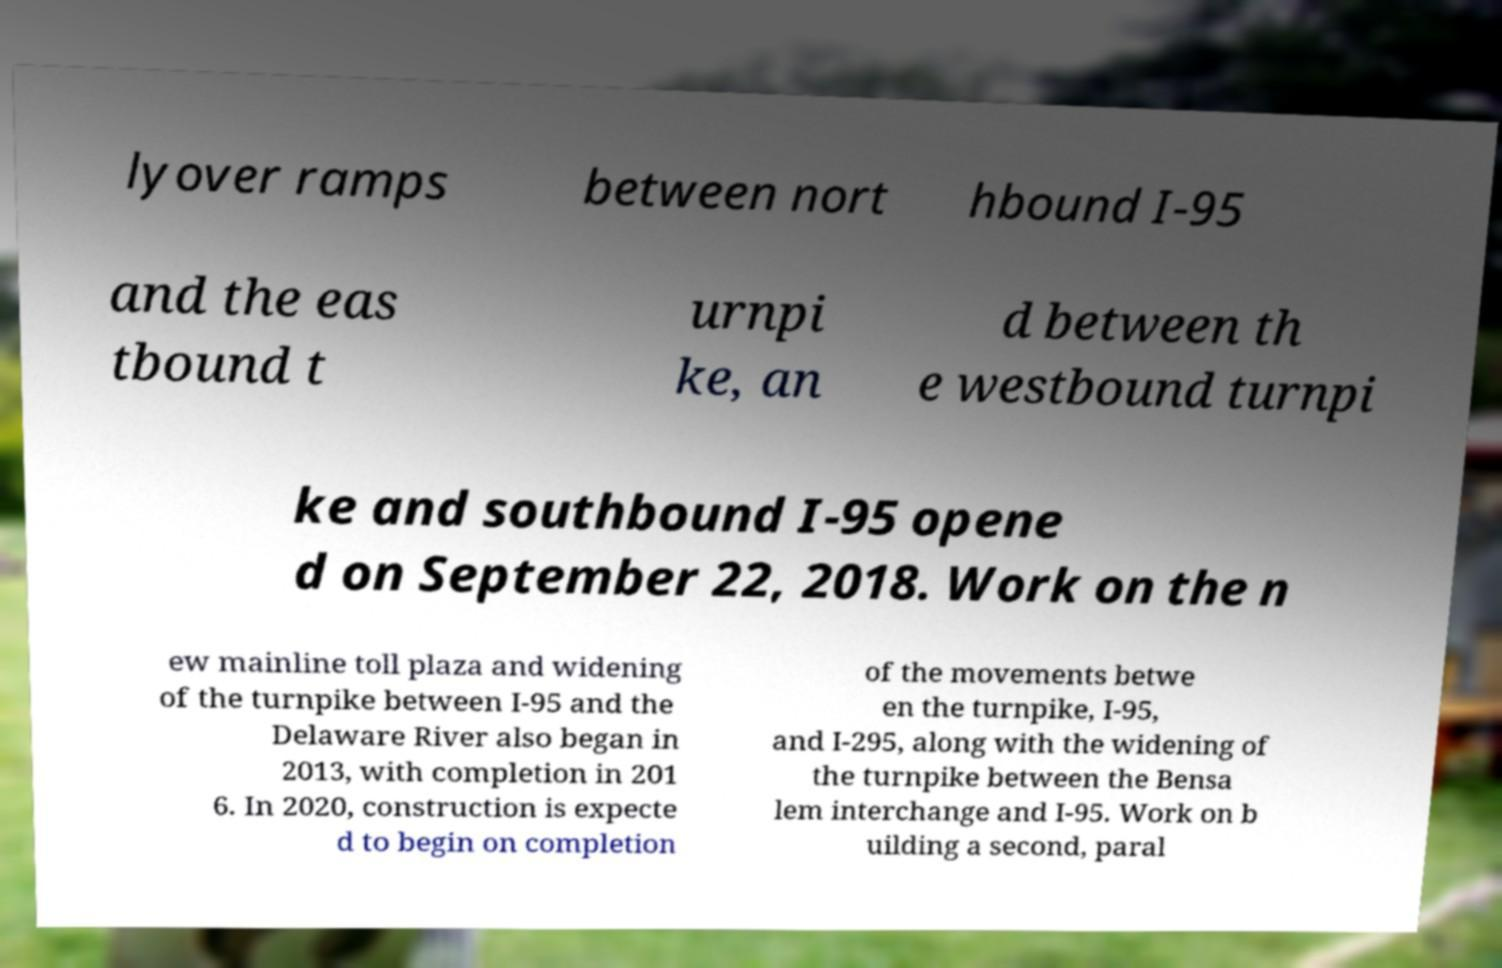Can you accurately transcribe the text from the provided image for me? lyover ramps between nort hbound I-95 and the eas tbound t urnpi ke, an d between th e westbound turnpi ke and southbound I-95 opene d on September 22, 2018. Work on the n ew mainline toll plaza and widening of the turnpike between I-95 and the Delaware River also began in 2013, with completion in 201 6. In 2020, construction is expecte d to begin on completion of the movements betwe en the turnpike, I-95, and I-295, along with the widening of the turnpike between the Bensa lem interchange and I-95. Work on b uilding a second, paral 